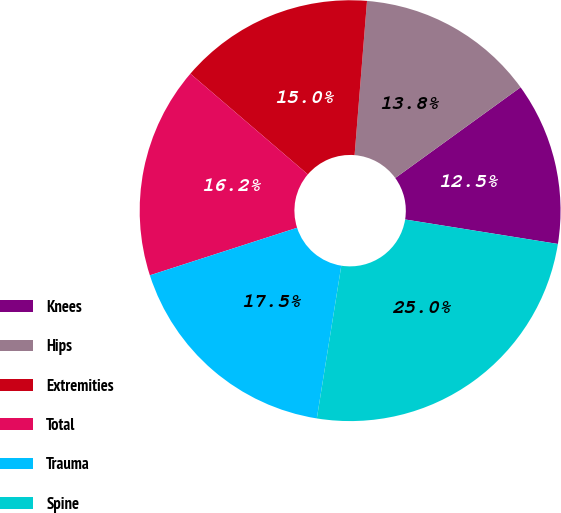<chart> <loc_0><loc_0><loc_500><loc_500><pie_chart><fcel>Knees<fcel>Hips<fcel>Extremities<fcel>Total<fcel>Trauma<fcel>Spine<nl><fcel>12.5%<fcel>13.75%<fcel>15.0%<fcel>16.25%<fcel>17.5%<fcel>25.0%<nl></chart> 